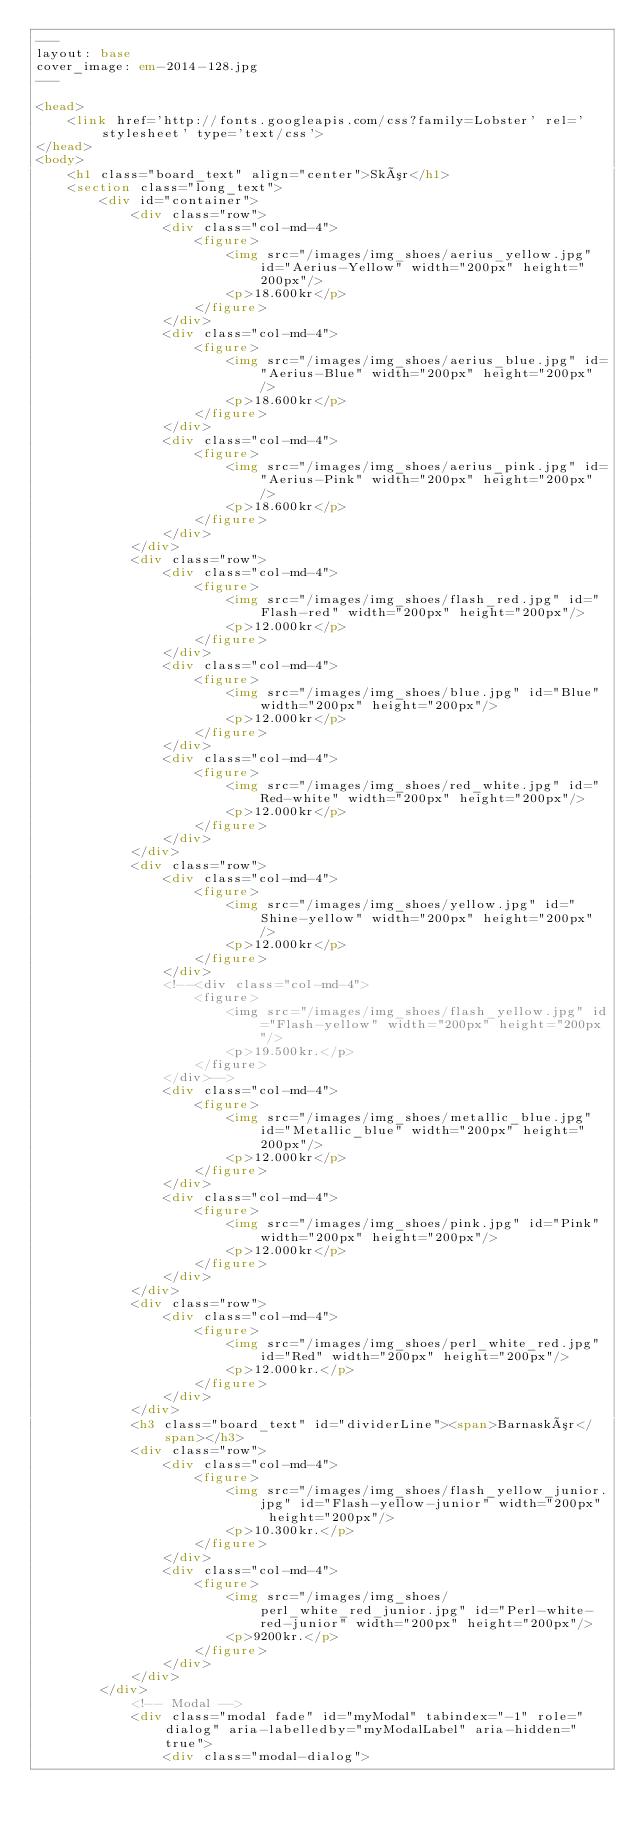Convert code to text. <code><loc_0><loc_0><loc_500><loc_500><_HTML_>---
layout: base
cover_image: em-2014-128.jpg
---

<head>
	<link href='http://fonts.googleapis.com/css?family=Lobster' rel='stylesheet' type='text/css'>
</head>
<body>
	<h1 class="board_text" align="center">Skór</h1>
	<section class="long_text">
		<div id="container">
			<div class="row">
				<div class="col-md-4">
					<figure>
						<img src="/images/img_shoes/aerius_yellow.jpg" id="Aerius-Yellow" width="200px" height="200px"/>
						<p>18.600kr</p>
					</figure>
				</div>
				<div class="col-md-4">
					<figure>
						<img src="/images/img_shoes/aerius_blue.jpg" id="Aerius-Blue" width="200px" height="200px"/>
						<p>18.600kr</p>
					</figure>
				</div>
				<div class="col-md-4">
					<figure>
						<img src="/images/img_shoes/aerius_pink.jpg" id="Aerius-Pink" width="200px" height="200px"/>
						<p>18.600kr</p>
					</figure>
				</div>
			</div>
			<div class="row">
				<div class="col-md-4">
					<figure>
						<img src="/images/img_shoes/flash_red.jpg" id="Flash-red" width="200px" height="200px"/>
						<p>12.000kr</p>
					</figure>
				</div>
				<div class="col-md-4">
					<figure>
						<img src="/images/img_shoes/blue.jpg" id="Blue" width="200px" height="200px"/>
						<p>12.000kr</p>
					</figure>
				</div>
				<div class="col-md-4">
					<figure>
						<img src="/images/img_shoes/red_white.jpg" id="Red-white" width="200px" height="200px"/>
						<p>12.000kr</p>
					</figure>
				</div>
			</div>
			<div class="row">
				<div class="col-md-4">
					<figure>
						<img src="/images/img_shoes/yellow.jpg" id="Shine-yellow" width="200px" height="200px"/>
						<p>12.000kr</p>
					</figure>
				</div>
				<!--<div class="col-md-4">
					<figure>
						<img src="/images/img_shoes/flash_yellow.jpg" id="Flash-yellow" width="200px" height="200px"/>
						<p>19.500kr.</p>
					</figure>
				</div>-->
				<div class="col-md-4">
					<figure>
						<img src="/images/img_shoes/metallic_blue.jpg" id="Metallic_blue" width="200px" height="200px"/>
						<p>12.000kr</p>
					</figure>
				</div>
				<div class="col-md-4">
					<figure>
						<img src="/images/img_shoes/pink.jpg" id="Pink" width="200px" height="200px"/>
						<p>12.000kr</p>
					</figure>
				</div>
			</div>
			<div class="row">
				<div class="col-md-4">
					<figure>
						<img src="/images/img_shoes/perl_white_red.jpg" id="Red" width="200px" height="200px"/>
						<p>12.000kr.</p>
					</figure>
				</div>
			</div>
			<h3 class="board_text" id="dividerLine"><span>Barnaskór</span></h3>
			<div class="row">
				<div class="col-md-4">
					<figure>
						<img src="/images/img_shoes/flash_yellow_junior.jpg" id="Flash-yellow-junior" width="200px" height="200px"/>
						<p>10.300kr.</p>
					</figure>
				</div>
				<div class="col-md-4">
					<figure>
						<img src="/images/img_shoes/perl_white_red_junior.jpg" id="Perl-white-red-junior" width="200px" height="200px"/>
						<p>9200kr.</p>
					</figure>
				</div>
			</div>
		</div>
			<!-- Modal -->
			<div class="modal fade" id="myModal" tabindex="-1" role="dialog" aria-labelledby="myModalLabel" aria-hidden="true">
				<div class="modal-dialog"></code> 